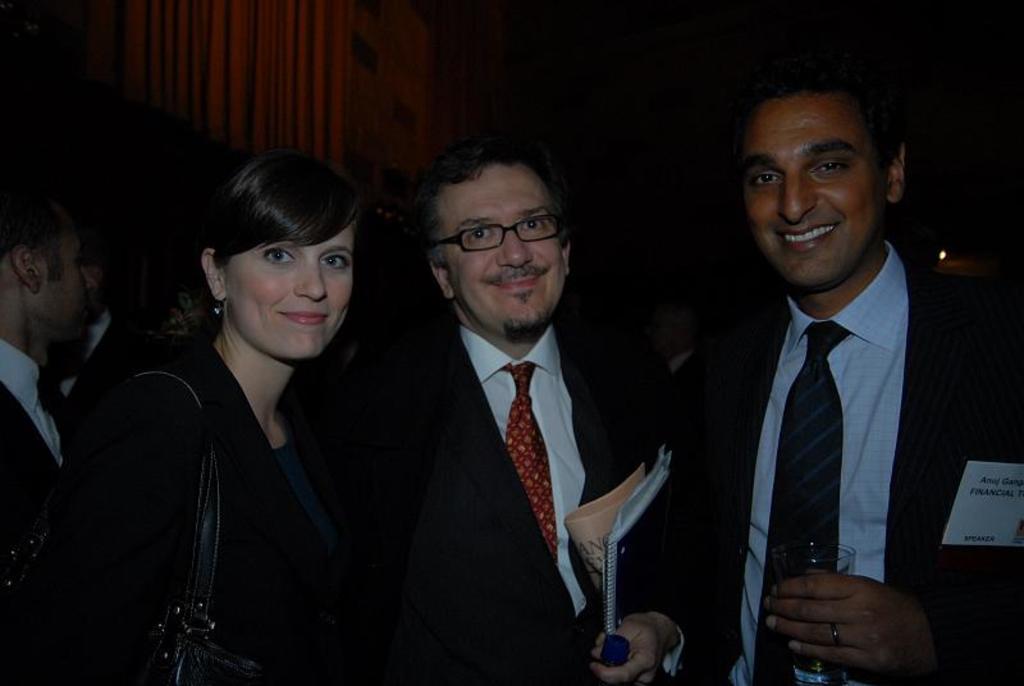In one or two sentences, can you explain what this image depicts? In this image, we can see a group of people. Few are holding some objects. Here we can see three people are smiling and seeing. Background we can see a dark view. 